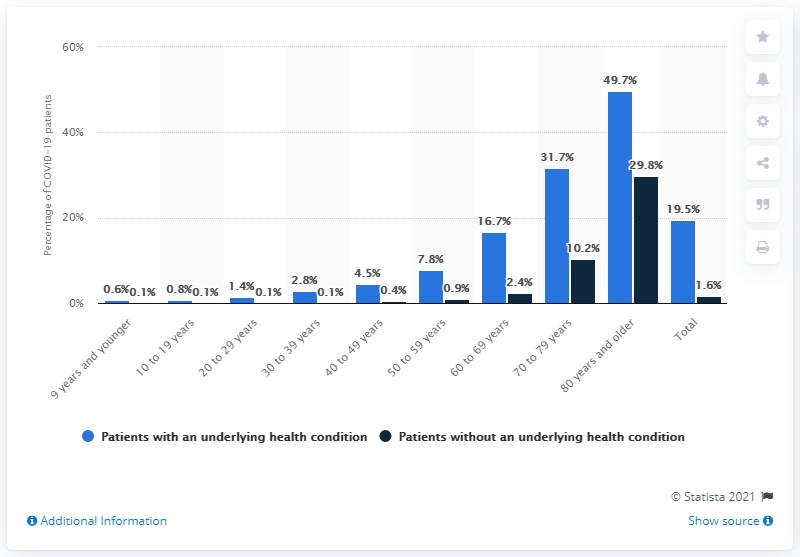Point out several critical features in this image. The difference between the maximum percentage of people with an underlying health condition and the minimum percentage of people without an underlying health condition over the years was 49.6%. According to the data, the age group with the highest percentage of deaths is individuals who are 80 years old and above. 